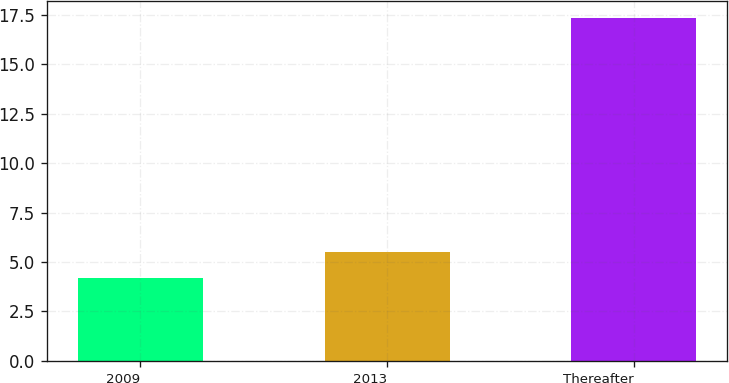Convert chart. <chart><loc_0><loc_0><loc_500><loc_500><bar_chart><fcel>2009<fcel>2013<fcel>Thereafter<nl><fcel>4.2<fcel>5.51<fcel>17.3<nl></chart> 